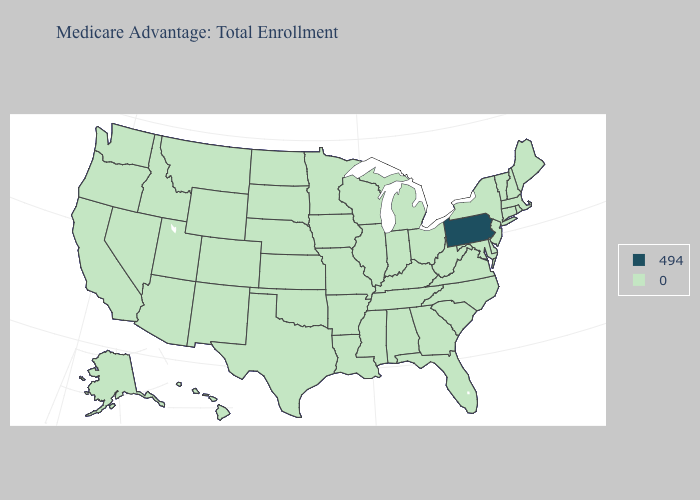Name the states that have a value in the range 0?
Give a very brief answer. Alaska, Alabama, Arkansas, Arizona, California, Colorado, Connecticut, Delaware, Florida, Georgia, Hawaii, Iowa, Idaho, Illinois, Indiana, Kansas, Kentucky, Louisiana, Massachusetts, Maryland, Maine, Michigan, Minnesota, Missouri, Mississippi, Montana, North Carolina, North Dakota, Nebraska, New Hampshire, New Jersey, New Mexico, Nevada, New York, Ohio, Oklahoma, Oregon, Rhode Island, South Carolina, South Dakota, Tennessee, Texas, Utah, Virginia, Vermont, Washington, Wisconsin, West Virginia, Wyoming. What is the lowest value in the USA?
Write a very short answer. 0. Name the states that have a value in the range 494?
Concise answer only. Pennsylvania. Among the states that border Louisiana , which have the lowest value?
Quick response, please. Arkansas, Mississippi, Texas. What is the value of Wyoming?
Be succinct. 0. What is the value of Nevada?
Keep it brief. 0. Which states hav the highest value in the South?
Short answer required. Alabama, Arkansas, Delaware, Florida, Georgia, Kentucky, Louisiana, Maryland, Mississippi, North Carolina, Oklahoma, South Carolina, Tennessee, Texas, Virginia, West Virginia. Name the states that have a value in the range 0?
Write a very short answer. Alaska, Alabama, Arkansas, Arizona, California, Colorado, Connecticut, Delaware, Florida, Georgia, Hawaii, Iowa, Idaho, Illinois, Indiana, Kansas, Kentucky, Louisiana, Massachusetts, Maryland, Maine, Michigan, Minnesota, Missouri, Mississippi, Montana, North Carolina, North Dakota, Nebraska, New Hampshire, New Jersey, New Mexico, Nevada, New York, Ohio, Oklahoma, Oregon, Rhode Island, South Carolina, South Dakota, Tennessee, Texas, Utah, Virginia, Vermont, Washington, Wisconsin, West Virginia, Wyoming. Which states hav the highest value in the MidWest?
Quick response, please. Iowa, Illinois, Indiana, Kansas, Michigan, Minnesota, Missouri, North Dakota, Nebraska, Ohio, South Dakota, Wisconsin. Does Washington have the same value as Pennsylvania?
Concise answer only. No. What is the value of South Dakota?
Give a very brief answer. 0. What is the value of Maryland?
Write a very short answer. 0. Does the first symbol in the legend represent the smallest category?
Answer briefly. No. 